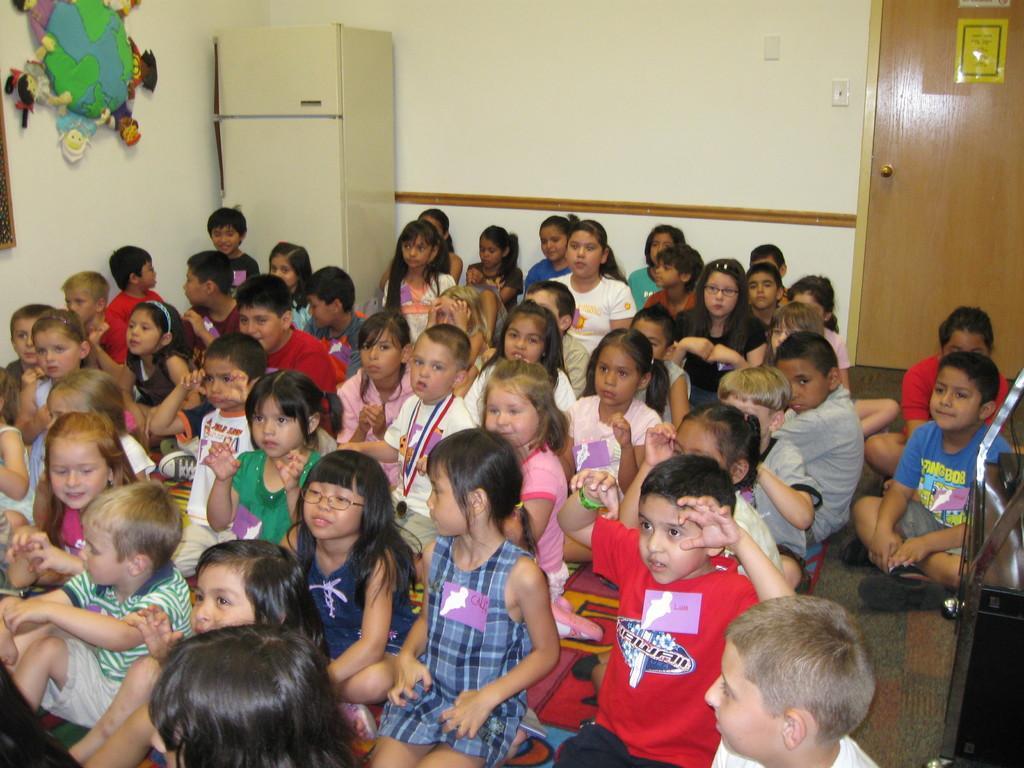Can you describe this image briefly? In this image we can see, there are many children sitting, and looking at someone and at the right, we can see the door, and on the left side we can see the fridge and something is on the wall. 